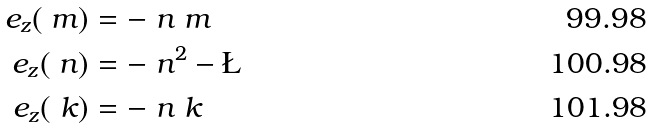Convert formula to latex. <formula><loc_0><loc_0><loc_500><loc_500>e _ { z } ( \ m ) & = - \ n \ m \\ e _ { z } ( \ n ) & = - \ n ^ { 2 } - \L \\ e _ { z } ( \ k ) & = - \ n \ k</formula> 